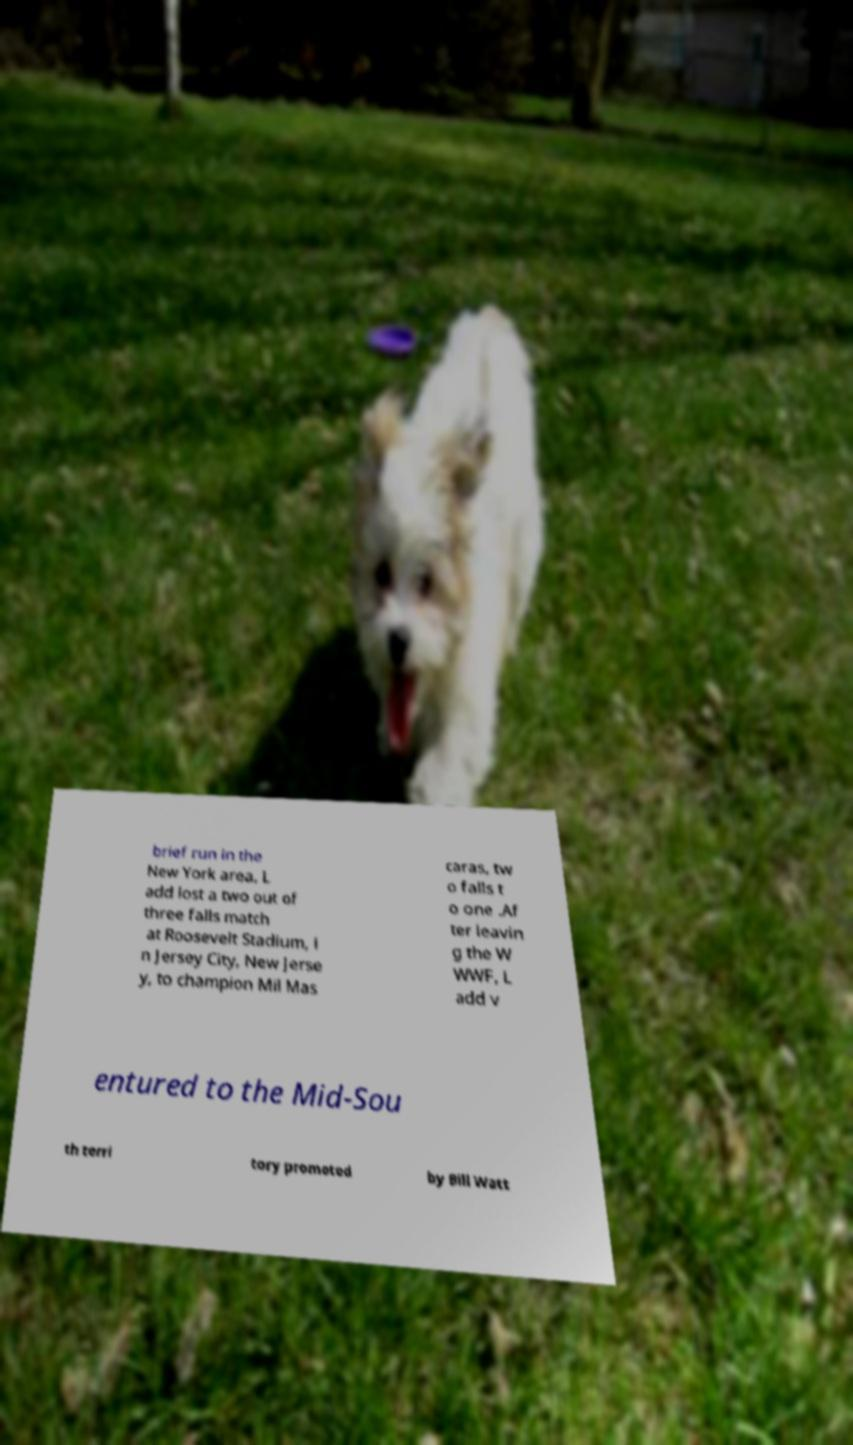Could you assist in decoding the text presented in this image and type it out clearly? brief run in the New York area, L add lost a two out of three falls match at Roosevelt Stadium, i n Jersey City, New Jerse y, to champion Mil Mas caras, tw o falls t o one .Af ter leavin g the W WWF, L add v entured to the Mid-Sou th terri tory promoted by Bill Watt 